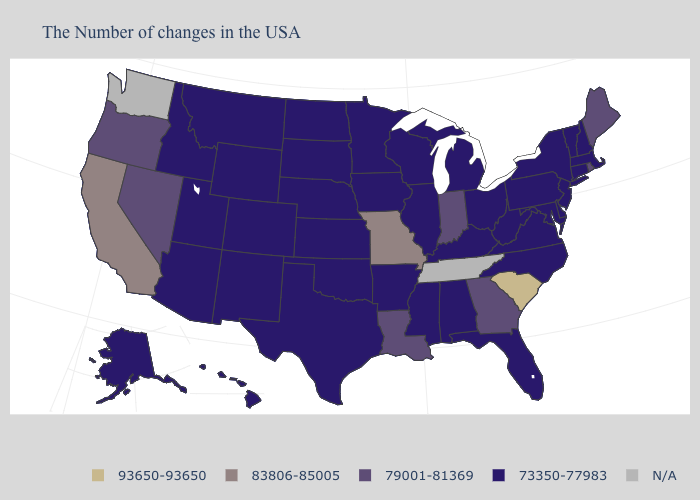Name the states that have a value in the range 79001-81369?
Short answer required. Maine, Rhode Island, Georgia, Indiana, Louisiana, Nevada, Oregon. Which states have the lowest value in the USA?
Answer briefly. Massachusetts, New Hampshire, Vermont, Connecticut, New York, New Jersey, Delaware, Maryland, Pennsylvania, Virginia, North Carolina, West Virginia, Ohio, Florida, Michigan, Kentucky, Alabama, Wisconsin, Illinois, Mississippi, Arkansas, Minnesota, Iowa, Kansas, Nebraska, Oklahoma, Texas, South Dakota, North Dakota, Wyoming, Colorado, New Mexico, Utah, Montana, Arizona, Idaho, Alaska, Hawaii. What is the value of Georgia?
Give a very brief answer. 79001-81369. Among the states that border Utah , which have the lowest value?
Quick response, please. Wyoming, Colorado, New Mexico, Arizona, Idaho. What is the lowest value in the West?
Be succinct. 73350-77983. Which states hav the highest value in the MidWest?
Short answer required. Missouri. Name the states that have a value in the range 83806-85005?
Short answer required. Missouri, California. Among the states that border New Mexico , which have the highest value?
Short answer required. Oklahoma, Texas, Colorado, Utah, Arizona. What is the value of North Carolina?
Concise answer only. 73350-77983. Name the states that have a value in the range 79001-81369?
Give a very brief answer. Maine, Rhode Island, Georgia, Indiana, Louisiana, Nevada, Oregon. Does Georgia have the lowest value in the South?
Be succinct. No. Among the states that border Florida , does Georgia have the lowest value?
Keep it brief. No. What is the value of Indiana?
Keep it brief. 79001-81369. What is the value of Utah?
Concise answer only. 73350-77983. Name the states that have a value in the range 73350-77983?
Write a very short answer. Massachusetts, New Hampshire, Vermont, Connecticut, New York, New Jersey, Delaware, Maryland, Pennsylvania, Virginia, North Carolina, West Virginia, Ohio, Florida, Michigan, Kentucky, Alabama, Wisconsin, Illinois, Mississippi, Arkansas, Minnesota, Iowa, Kansas, Nebraska, Oklahoma, Texas, South Dakota, North Dakota, Wyoming, Colorado, New Mexico, Utah, Montana, Arizona, Idaho, Alaska, Hawaii. 